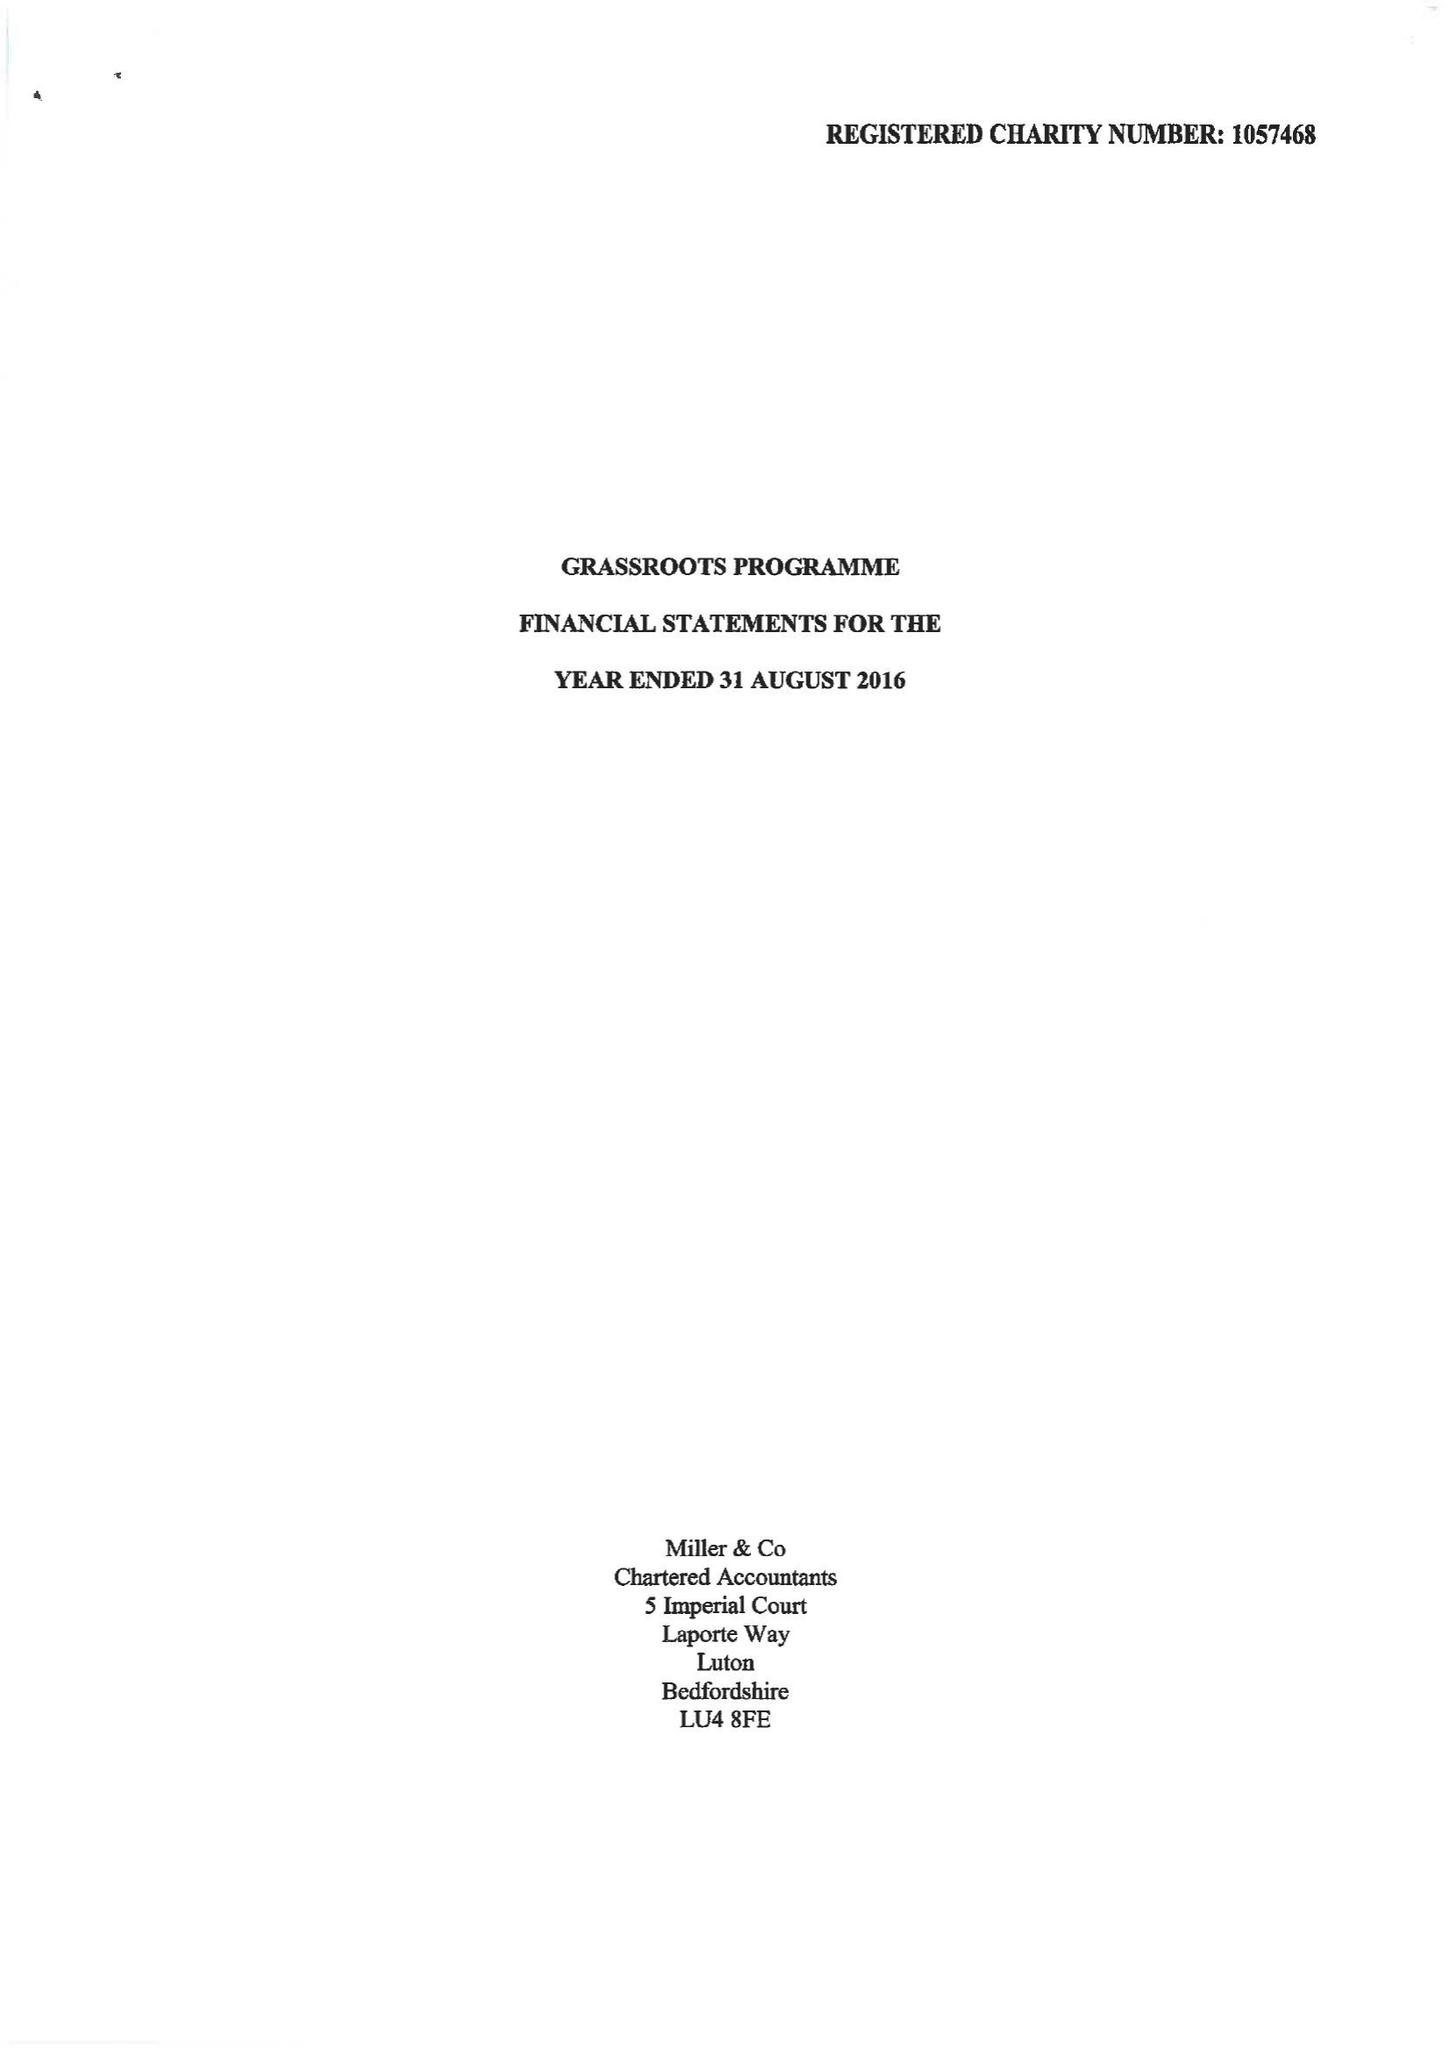What is the value for the income_annually_in_british_pounds?
Answer the question using a single word or phrase. 128388.00 